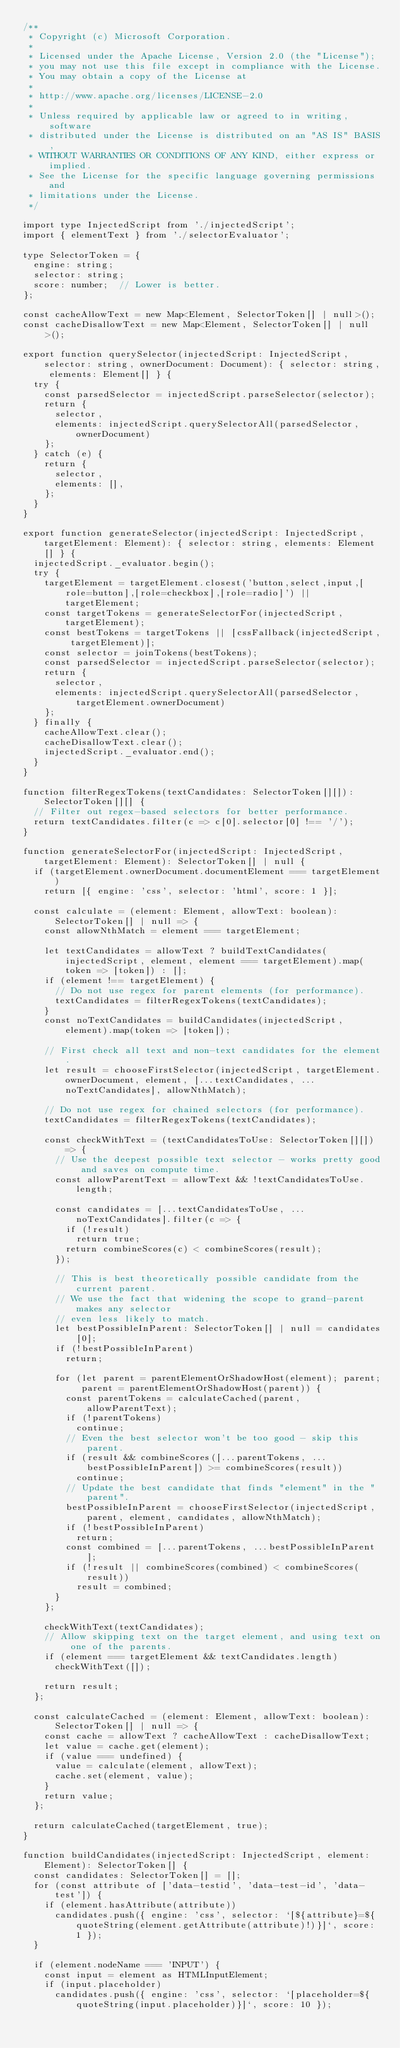<code> <loc_0><loc_0><loc_500><loc_500><_TypeScript_>/**
 * Copyright (c) Microsoft Corporation.
 *
 * Licensed under the Apache License, Version 2.0 (the "License");
 * you may not use this file except in compliance with the License.
 * You may obtain a copy of the License at
 *
 * http://www.apache.org/licenses/LICENSE-2.0
 *
 * Unless required by applicable law or agreed to in writing, software
 * distributed under the License is distributed on an "AS IS" BASIS,
 * WITHOUT WARRANTIES OR CONDITIONS OF ANY KIND, either express or implied.
 * See the License for the specific language governing permissions and
 * limitations under the License.
 */

import type InjectedScript from './injectedScript';
import { elementText } from './selectorEvaluator';

type SelectorToken = {
  engine: string;
  selector: string;
  score: number;  // Lower is better.
};

const cacheAllowText = new Map<Element, SelectorToken[] | null>();
const cacheDisallowText = new Map<Element, SelectorToken[] | null>();

export function querySelector(injectedScript: InjectedScript, selector: string, ownerDocument: Document): { selector: string, elements: Element[] } {
  try {
    const parsedSelector = injectedScript.parseSelector(selector);
    return {
      selector,
      elements: injectedScript.querySelectorAll(parsedSelector, ownerDocument)
    };
  } catch (e) {
    return {
      selector,
      elements: [],
    };
  }
}

export function generateSelector(injectedScript: InjectedScript, targetElement: Element): { selector: string, elements: Element[] } {
  injectedScript._evaluator.begin();
  try {
    targetElement = targetElement.closest('button,select,input,[role=button],[role=checkbox],[role=radio]') || targetElement;
    const targetTokens = generateSelectorFor(injectedScript, targetElement);
    const bestTokens = targetTokens || [cssFallback(injectedScript, targetElement)];
    const selector = joinTokens(bestTokens);
    const parsedSelector = injectedScript.parseSelector(selector);
    return {
      selector,
      elements: injectedScript.querySelectorAll(parsedSelector, targetElement.ownerDocument)
    };
  } finally {
    cacheAllowText.clear();
    cacheDisallowText.clear();
    injectedScript._evaluator.end();
  }
}

function filterRegexTokens(textCandidates: SelectorToken[][]): SelectorToken[][] {
  // Filter out regex-based selectors for better performance.
  return textCandidates.filter(c => c[0].selector[0] !== '/');
}

function generateSelectorFor(injectedScript: InjectedScript, targetElement: Element): SelectorToken[] | null {
  if (targetElement.ownerDocument.documentElement === targetElement)
    return [{ engine: 'css', selector: 'html', score: 1 }];

  const calculate = (element: Element, allowText: boolean): SelectorToken[] | null => {
    const allowNthMatch = element === targetElement;

    let textCandidates = allowText ? buildTextCandidates(injectedScript, element, element === targetElement).map(token => [token]) : [];
    if (element !== targetElement) {
      // Do not use regex for parent elements (for performance).
      textCandidates = filterRegexTokens(textCandidates);
    }
    const noTextCandidates = buildCandidates(injectedScript, element).map(token => [token]);

    // First check all text and non-text candidates for the element.
    let result = chooseFirstSelector(injectedScript, targetElement.ownerDocument, element, [...textCandidates, ...noTextCandidates], allowNthMatch);

    // Do not use regex for chained selectors (for performance).
    textCandidates = filterRegexTokens(textCandidates);

    const checkWithText = (textCandidatesToUse: SelectorToken[][]) => {
      // Use the deepest possible text selector - works pretty good and saves on compute time.
      const allowParentText = allowText && !textCandidatesToUse.length;

      const candidates = [...textCandidatesToUse, ...noTextCandidates].filter(c => {
        if (!result)
          return true;
        return combineScores(c) < combineScores(result);
      });

      // This is best theoretically possible candidate from the current parent.
      // We use the fact that widening the scope to grand-parent makes any selector
      // even less likely to match.
      let bestPossibleInParent: SelectorToken[] | null = candidates[0];
      if (!bestPossibleInParent)
        return;

      for (let parent = parentElementOrShadowHost(element); parent; parent = parentElementOrShadowHost(parent)) {
        const parentTokens = calculateCached(parent, allowParentText);
        if (!parentTokens)
          continue;
        // Even the best selector won't be too good - skip this parent.
        if (result && combineScores([...parentTokens, ...bestPossibleInParent]) >= combineScores(result))
          continue;
        // Update the best candidate that finds "element" in the "parent".
        bestPossibleInParent = chooseFirstSelector(injectedScript, parent, element, candidates, allowNthMatch);
        if (!bestPossibleInParent)
          return;
        const combined = [...parentTokens, ...bestPossibleInParent];
        if (!result || combineScores(combined) < combineScores(result))
          result = combined;
      }
    };

    checkWithText(textCandidates);
    // Allow skipping text on the target element, and using text on one of the parents.
    if (element === targetElement && textCandidates.length)
      checkWithText([]);

    return result;
  };

  const calculateCached = (element: Element, allowText: boolean): SelectorToken[] | null => {
    const cache = allowText ? cacheAllowText : cacheDisallowText;
    let value = cache.get(element);
    if (value === undefined) {
      value = calculate(element, allowText);
      cache.set(element, value);
    }
    return value;
  };

  return calculateCached(targetElement, true);
}

function buildCandidates(injectedScript: InjectedScript, element: Element): SelectorToken[] {
  const candidates: SelectorToken[] = [];
  for (const attribute of ['data-testid', 'data-test-id', 'data-test']) {
    if (element.hasAttribute(attribute))
      candidates.push({ engine: 'css', selector: `[${attribute}=${quoteString(element.getAttribute(attribute)!)}]`, score: 1 });
  }

  if (element.nodeName === 'INPUT') {
    const input = element as HTMLInputElement;
    if (input.placeholder)
      candidates.push({ engine: 'css', selector: `[placeholder=${quoteString(input.placeholder)}]`, score: 10 });</code> 